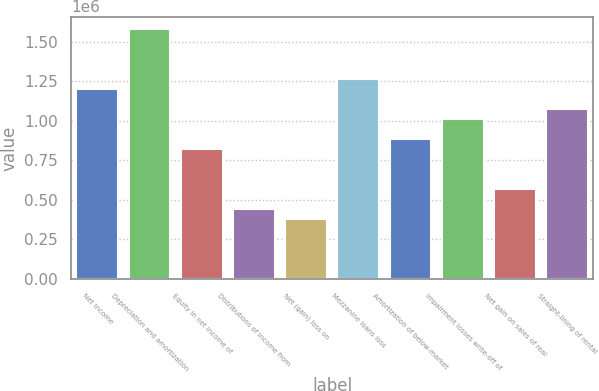Convert chart. <chart><loc_0><loc_0><loc_500><loc_500><bar_chart><fcel>Net income<fcel>Depreciation and amortization<fcel>Equity in net income of<fcel>Distributions of income from<fcel>Net (gain) loss on<fcel>Mezzanine loans loss<fcel>Amortization of below-market<fcel>Impairment losses write-off of<fcel>Net gain on sales of real<fcel>Straight-lining of rental<nl><fcel>1.20055e+06<fcel>1.57854e+06<fcel>822571<fcel>444587<fcel>381590<fcel>1.26355e+06<fcel>885568<fcel>1.01156e+06<fcel>570582<fcel>1.07456e+06<nl></chart> 